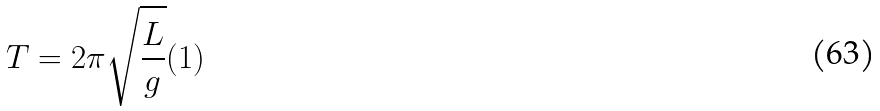Convert formula to latex. <formula><loc_0><loc_0><loc_500><loc_500>T = 2 \pi \sqrt { \frac { L } { g } } ( 1 )</formula> 